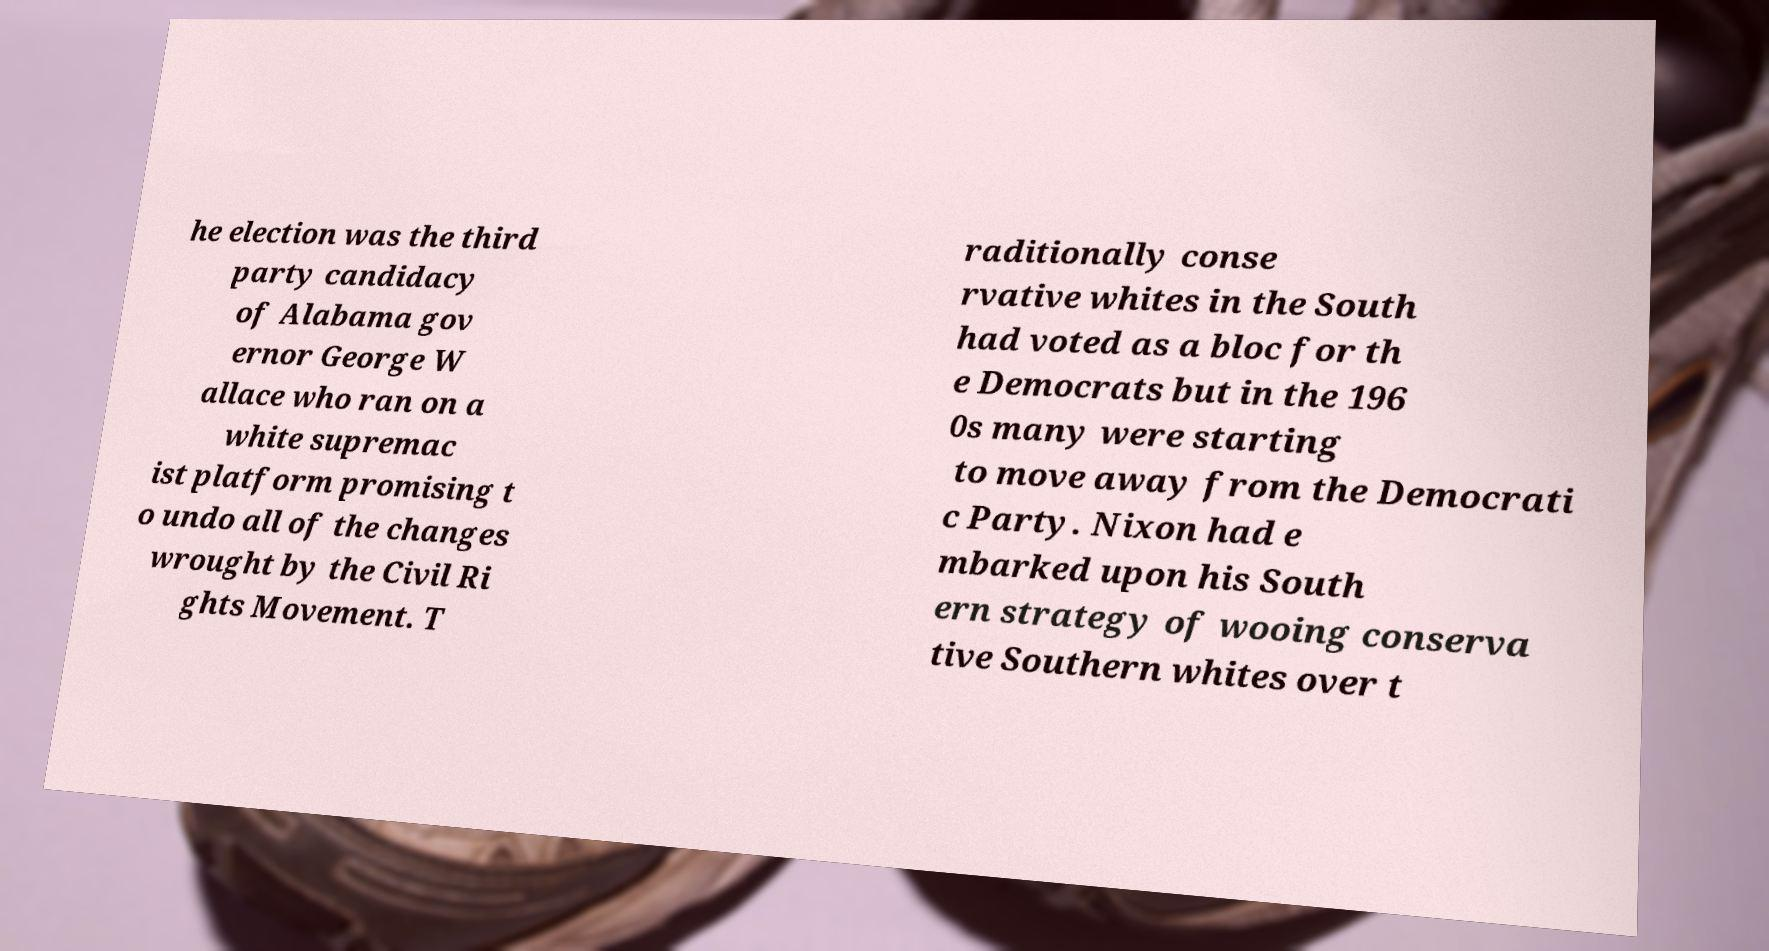Can you read and provide the text displayed in the image?This photo seems to have some interesting text. Can you extract and type it out for me? he election was the third party candidacy of Alabama gov ernor George W allace who ran on a white supremac ist platform promising t o undo all of the changes wrought by the Civil Ri ghts Movement. T raditionally conse rvative whites in the South had voted as a bloc for th e Democrats but in the 196 0s many were starting to move away from the Democrati c Party. Nixon had e mbarked upon his South ern strategy of wooing conserva tive Southern whites over t 